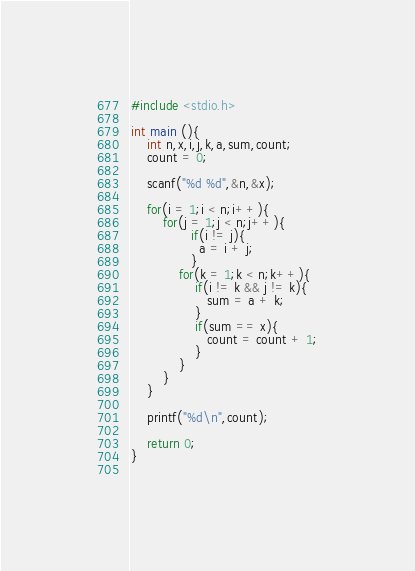<code> <loc_0><loc_0><loc_500><loc_500><_C_>#include <stdio.h>

int main (){
    int n,x,i,j,k,a,sum,count;
    count = 0;

    scanf("%d %d",&n,&x);
    
    for(i = 1;i < n;i++){
        for(j = 1;j < n;j++){
               if(i != j){
                 a = i + j;
               }
            for(k = 1;k < n;k++){
                if(i != k && j != k){
                   sum = a + k;
                }  
                if(sum == x){
                   count = count + 1;
                }
            }
        }
    }

    printf("%d\n",count);

    return 0;
}
                   </code> 